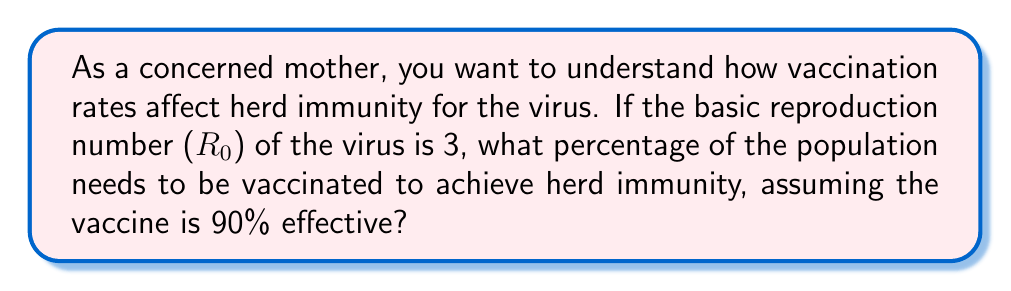Solve this math problem. To solve this problem, we need to understand the concept of herd immunity threshold and how it relates to vaccination rates. Let's break it down step-by-step:

1. The herd immunity threshold (HIT) is given by the formula:

   $$ HIT = 1 - \frac{1}{R_0} $$

   Where $R_0$ is the basic reproduction number.

2. Given $R_0 = 3$, we can calculate the HIT:

   $$ HIT = 1 - \frac{1}{3} = \frac{2}{3} \approx 0.6667 $$

   This means that approximately 66.67% of the population needs to be immune to achieve herd immunity.

3. However, the vaccine is not 100% effective. It's given as 90% effective. To account for this, we need to adjust our calculation:

   Let $x$ be the fraction of the population that needs to be vaccinated.
   
   $$ 0.90x = 0.6667 $$

4. Solving for $x$:

   $$ x = \frac{0.6667}{0.90} \approx 0.7407 $$

5. Convert to a percentage:

   $$ 0.7407 \times 100\% = 74.07\% $$

Therefore, approximately 74.07% of the population needs to be vaccinated to achieve herd immunity, given the vaccine's 90% effectiveness.
Answer: 74.07% of the population needs to be vaccinated to achieve herd immunity. 